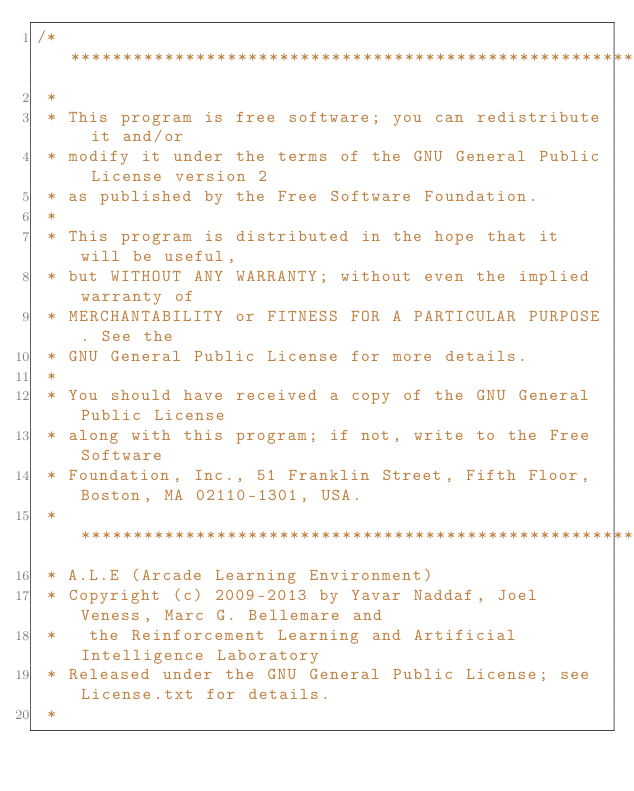<code> <loc_0><loc_0><loc_500><loc_500><_C++_>/* *****************************************************************************
 *
 * This program is free software; you can redistribute it and/or
 * modify it under the terms of the GNU General Public License version 2
 * as published by the Free Software Foundation.
 *
 * This program is distributed in the hope that it will be useful,
 * but WITHOUT ANY WARRANTY; without even the implied warranty of
 * MERCHANTABILITY or FITNESS FOR A PARTICULAR PURPOSE. See the
 * GNU General Public License for more details.
 *
 * You should have received a copy of the GNU General Public License
 * along with this program; if not, write to the Free Software
 * Foundation, Inc., 51 Franklin Street, Fifth Floor, Boston, MA 02110-1301, USA.
 * *****************************************************************************
 * A.L.E (Arcade Learning Environment)
 * Copyright (c) 2009-2013 by Yavar Naddaf, Joel Veness, Marc G. Bellemare and 
 *   the Reinforcement Learning and Artificial Intelligence Laboratory
 * Released under the GNU General Public License; see License.txt for details. 
 *</code> 